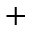<formula> <loc_0><loc_0><loc_500><loc_500>^ { + }</formula> 